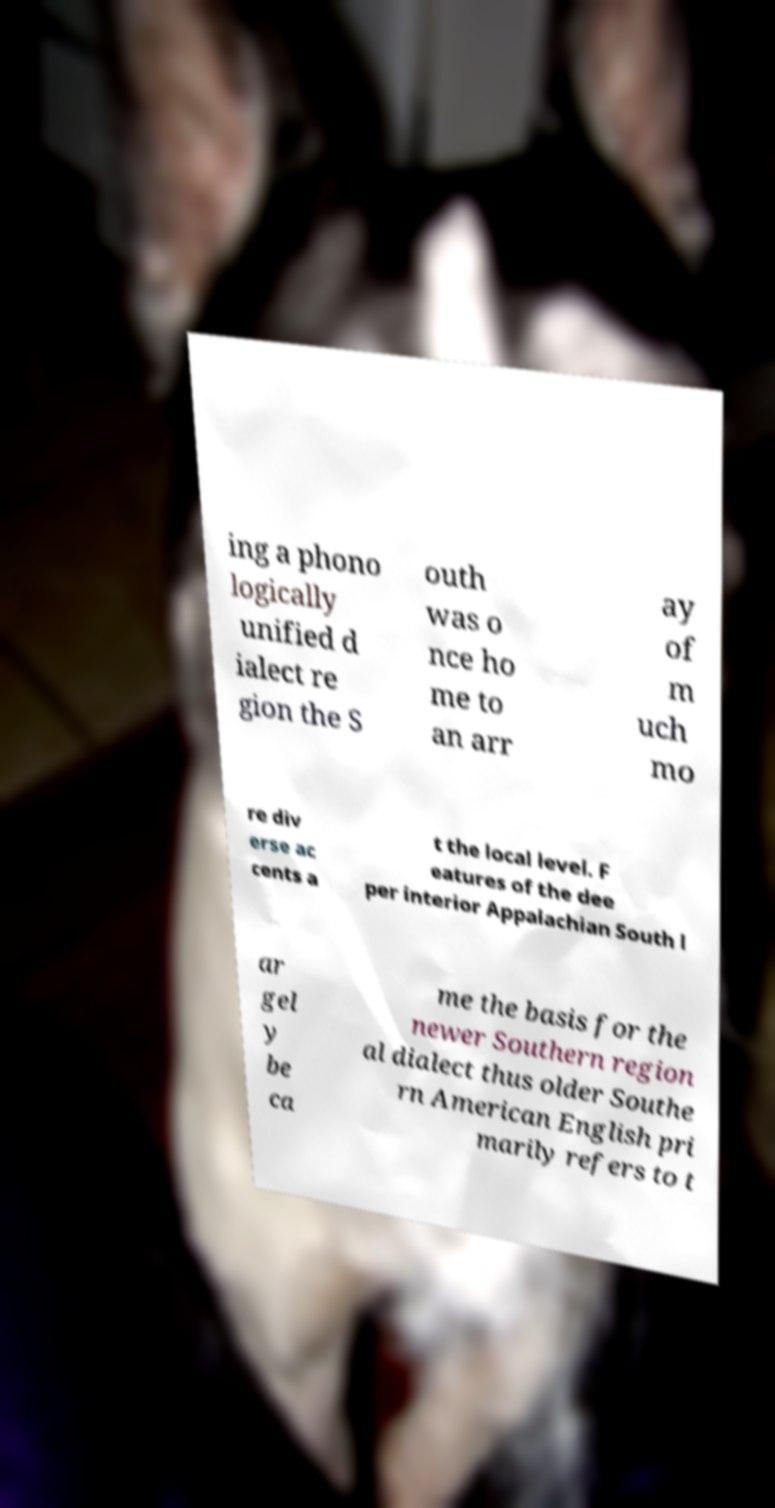Could you assist in decoding the text presented in this image and type it out clearly? ing a phono logically unified d ialect re gion the S outh was o nce ho me to an arr ay of m uch mo re div erse ac cents a t the local level. F eatures of the dee per interior Appalachian South l ar gel y be ca me the basis for the newer Southern region al dialect thus older Southe rn American English pri marily refers to t 